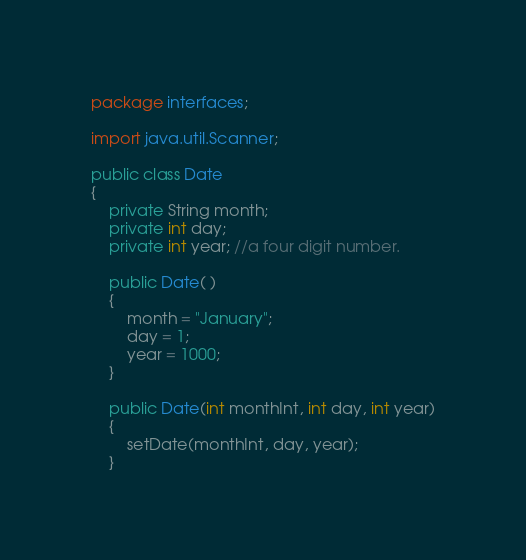Convert code to text. <code><loc_0><loc_0><loc_500><loc_500><_Java_>package interfaces;

import java.util.Scanner;

public class Date
{
    private String month;
    private int day;
    private int year; //a four digit number.

    public Date( )
    {
        month = "January";
        day = 1;
        year = 1000;
    }

    public Date(int monthInt, int day, int year)
    {
        setDate(monthInt, day, year);
    }
</code> 